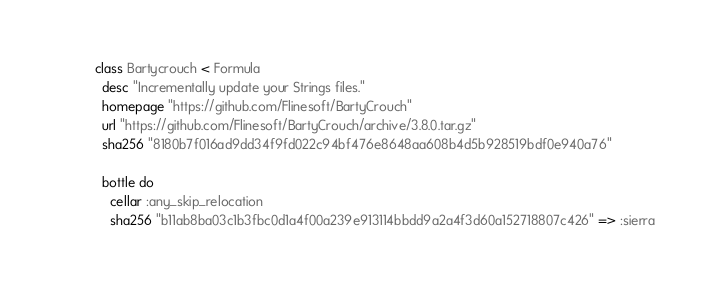Convert code to text. <code><loc_0><loc_0><loc_500><loc_500><_Ruby_>class Bartycrouch < Formula
  desc "Incrementally update your Strings files."
  homepage "https://github.com/Flinesoft/BartyCrouch"
  url "https://github.com/Flinesoft/BartyCrouch/archive/3.8.0.tar.gz"
  sha256 "8180b7f016ad9dd34f9fd022c94bf476e8648aa608b4d5b928519bdf0e940a76"

  bottle do
    cellar :any_skip_relocation
    sha256 "b11ab8ba03c1b3fbc0d1a4f00a239e913114bbdd9a2a4f3d60a152718807c426" => :sierra</code> 